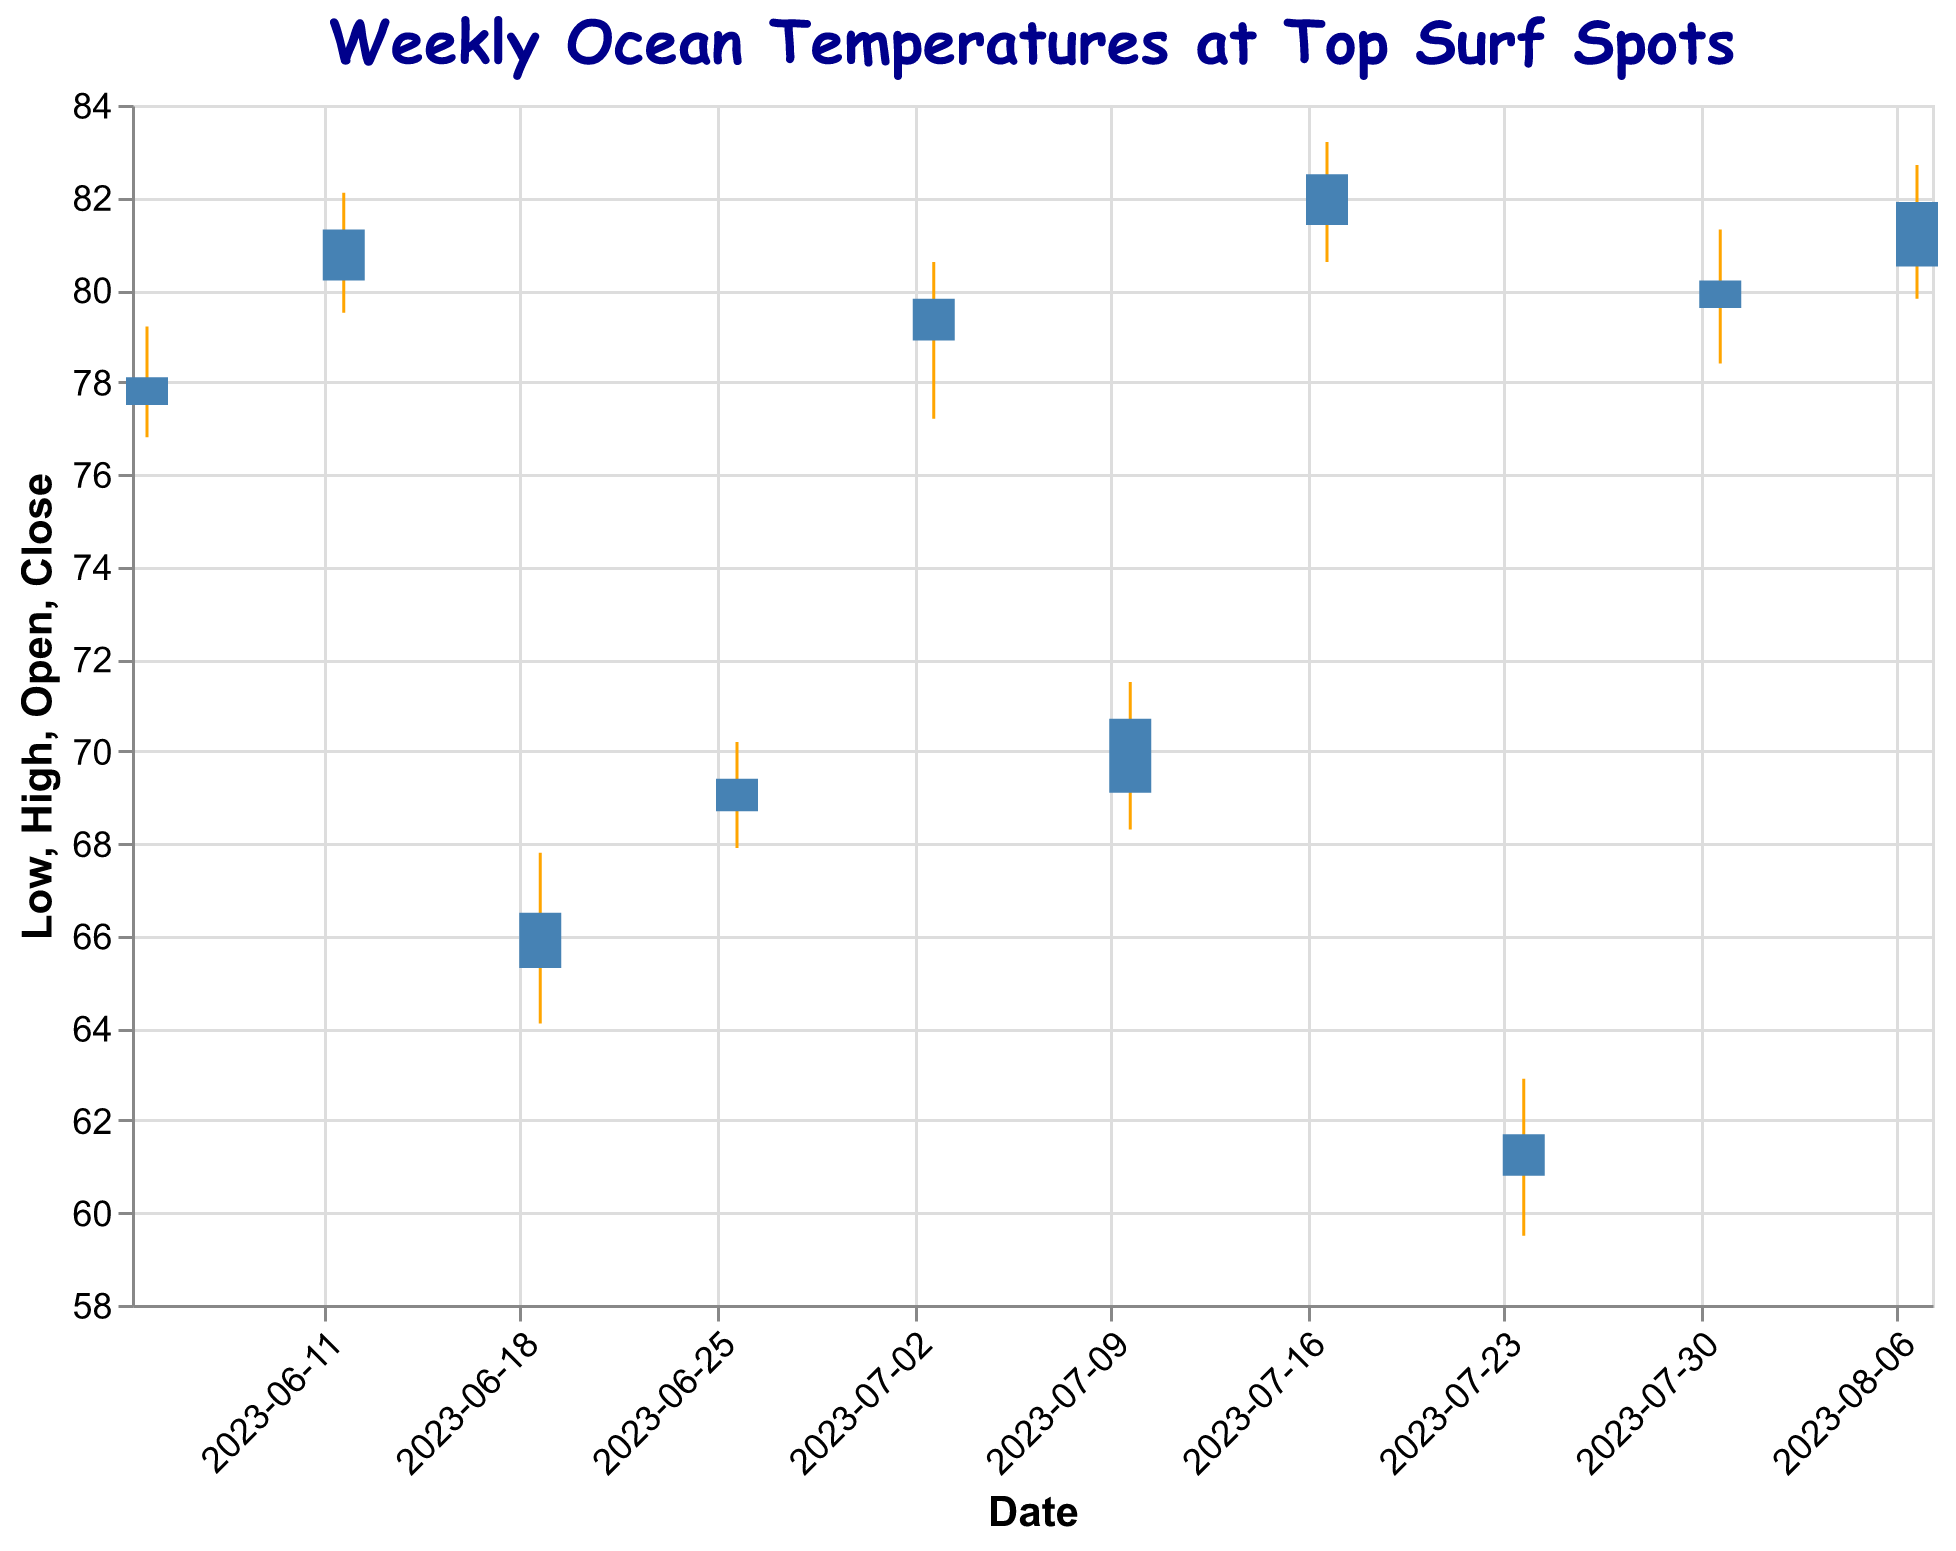What is the title of the chart? The title of the chart is located at the top of the figure and serves to indicate the main subject of the data being displayed. The text is also customized to use a specific font and color.
Answer: Weekly Ocean Temperatures at Top Surf Spots How many different surf locations are shown in the chart? We can count the unique surf locations listed on the chart, with each location corresponding to a specific date. There are 10 different dates, each with a unique location.
Answer: 10 Which surf spot had the highest ocean temperature during the week of July 17, 2023? To find this, we locate the bar and line associated with July 17, 2023 (Cloudbreak, Fiji) and then identify the highest point on the vertical axis for that week. The highest temperature is shown by the High value of 83.2°F.
Answer: Cloudbreak (Fiji) What was the ocean temperature range (difference between high and low) for Mavericks, California, during the week of July 24, 2023? Locate the week of July 24, 2023, and find the High and Low values for Mavericks, California. Subtract the Low value from the High value to get the range (62.9 - 59.5 = 3.4°F).
Answer: 3.4°F During which week did Teahupo'o, Tahiti have an opening temperature of 80.2°F? By examining the bars for each week, we locate the bar for Teahupo'o, Tahiti, and find the week associated with an opening temperature of 80.2°F, which is the week of June 12, 2023.
Answer: Week of June 12, 2023 Compare the closing temperatures of Jeffreys Bay (South Africa) on June 26, 2023, and Waimea Bay (Hawaii) on July 31, 2023. Which location had a higher closing temperature and by how much? First, find the closing temperatures for both dates: Jeffreys Bay on June 26 is 69.4°F and Waimea Bay on July 31 is 80.2°F. Subtract the lower value from the higher value (80.2 - 69.4 = 10.8°F). Waimea Bay had a higher closing temperature by 10.8°F.
Answer: Waimea Bay, 10.8°F What was the average closing temperature of all surf spots across all weeks? To calculate the average closing temperature, sum up the closing temperatures for all the weeks and divide by the number of weeks. Closing temperatures: 78.1 + 81.3 + 66.5 + 69.4 + 79.8 + 70.7 + 82.5 + 61.7 + 80.2 + 81.9 = 752.1°F. Divide by 10 weeks: 752.1 / 10 = 75.21°F.
Answer: 75.21°F Which location had the most stable temperature (smallest difference between high and low) during its week? To determine this, compute the temperature range for each location by subtracting the Low value from the High value and identify the smallest difference. The differences are as follows: Pipeline (Hawaii) 2.4, Teahupo'o (Tahiti) 2.6, Nazaré (Portugal) 3.7, Jeffreys Bay (South Africa) 2.3, Banzai Pipeline (Hawaii) 3.4, Supertubes (South Africa) 3.2, Cloudbreak (Fiji) 2.6, Mavericks (California) 3.4, Waimea Bay (Hawaii) 2.9, Peahi (Jaws) (Hawaii) 2.9. The most stable temperature was at Jeffreys Bay, South Africa with a difference of 2.3°F.
Answer: Jeffreys Bay (South Africa) What is the color used for the bars representing the opening and closing temperatures? The color of the bars on the chart can be identified by visual inspection. The bars are colored in a shade of steel blue.
Answer: Steel blue 